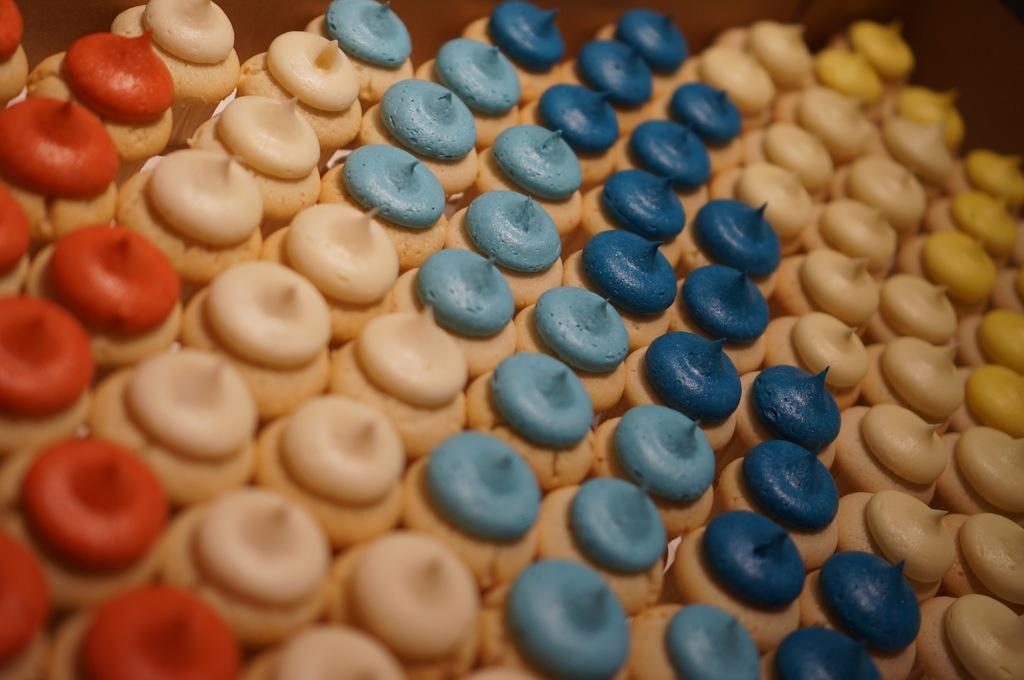How would you summarize this image in a sentence or two? There are cupcakes with different color cream on that. 